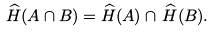<formula> <loc_0><loc_0><loc_500><loc_500>\widehat { H } ( A \cap B ) = \widehat { H } ( A ) \cap \, \widehat { H } ( B ) .</formula> 